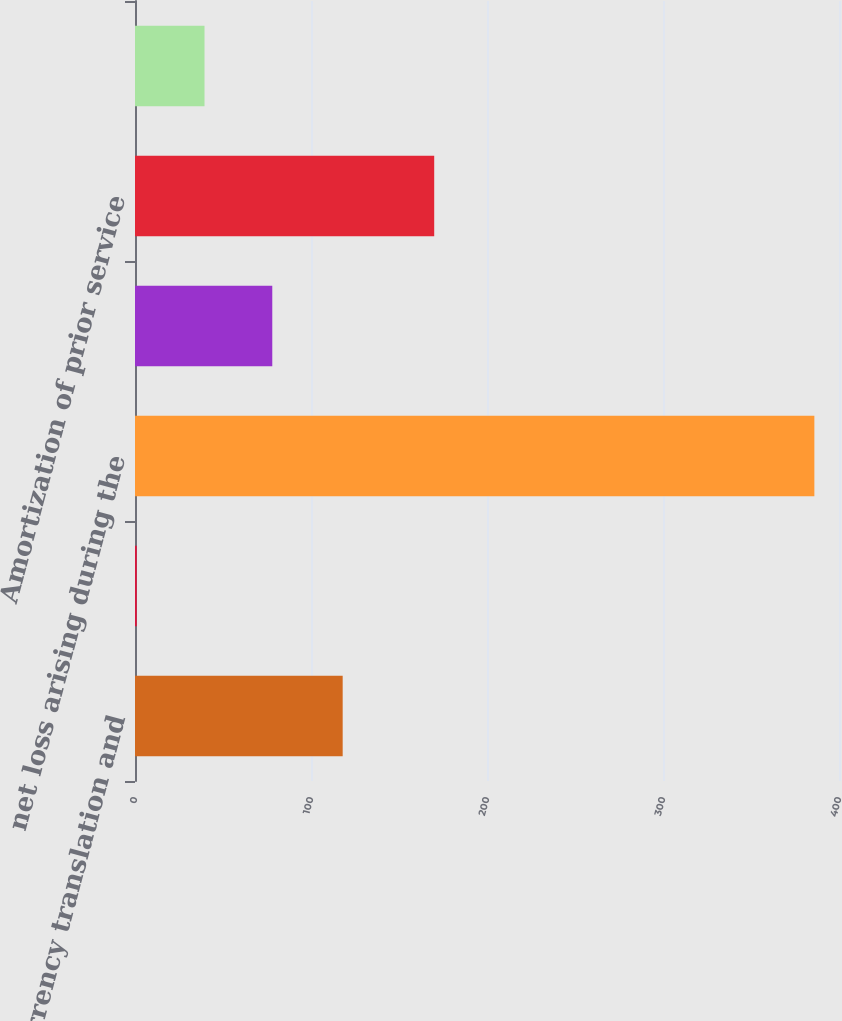Convert chart. <chart><loc_0><loc_0><loc_500><loc_500><bar_chart><fcel>Currency translation and<fcel>Prior service cost arising<fcel>net loss arising during the<fcel>Currency translation<fcel>Amortization of prior service<fcel>Gain (loss) on derivatives<nl><fcel>118<fcel>1<fcel>386<fcel>78<fcel>170<fcel>39.5<nl></chart> 